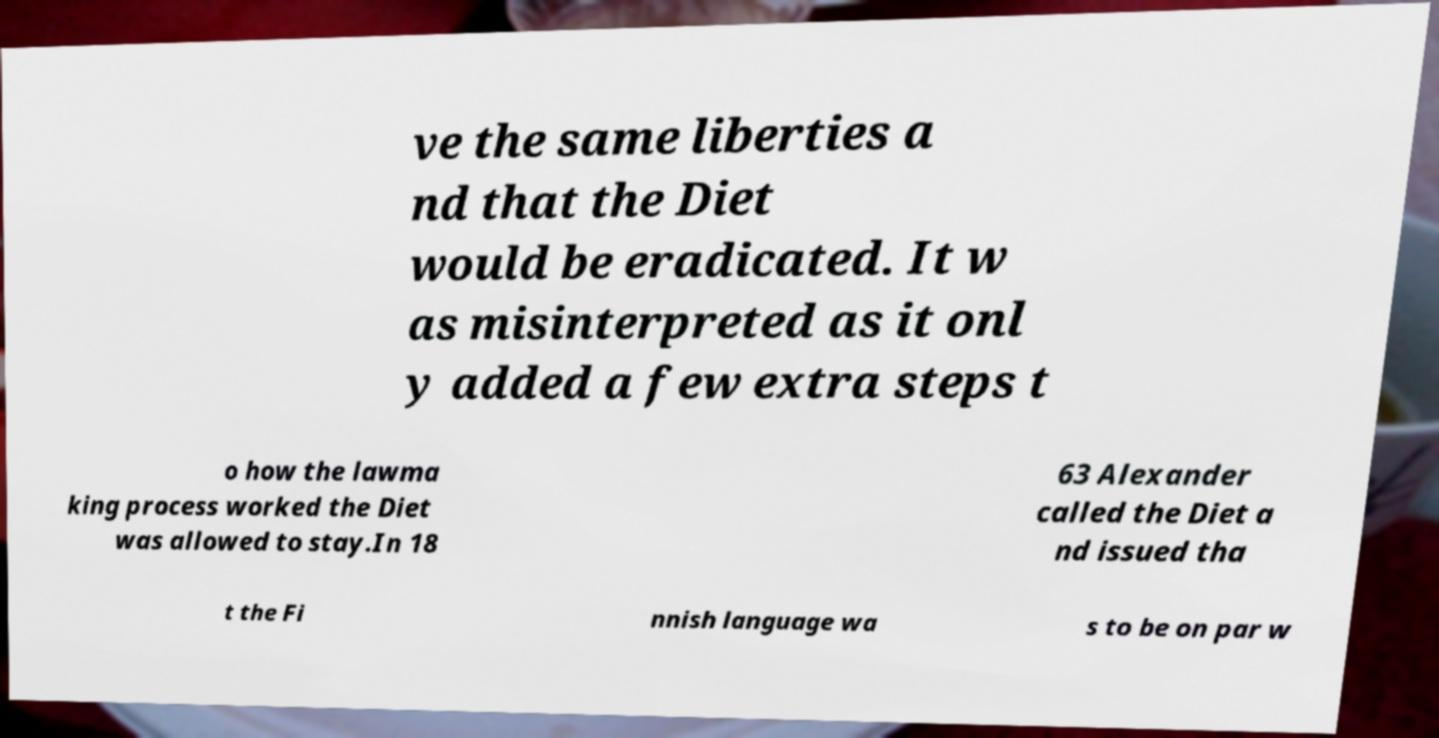Please identify and transcribe the text found in this image. ve the same liberties a nd that the Diet would be eradicated. It w as misinterpreted as it onl y added a few extra steps t o how the lawma king process worked the Diet was allowed to stay.In 18 63 Alexander called the Diet a nd issued tha t the Fi nnish language wa s to be on par w 